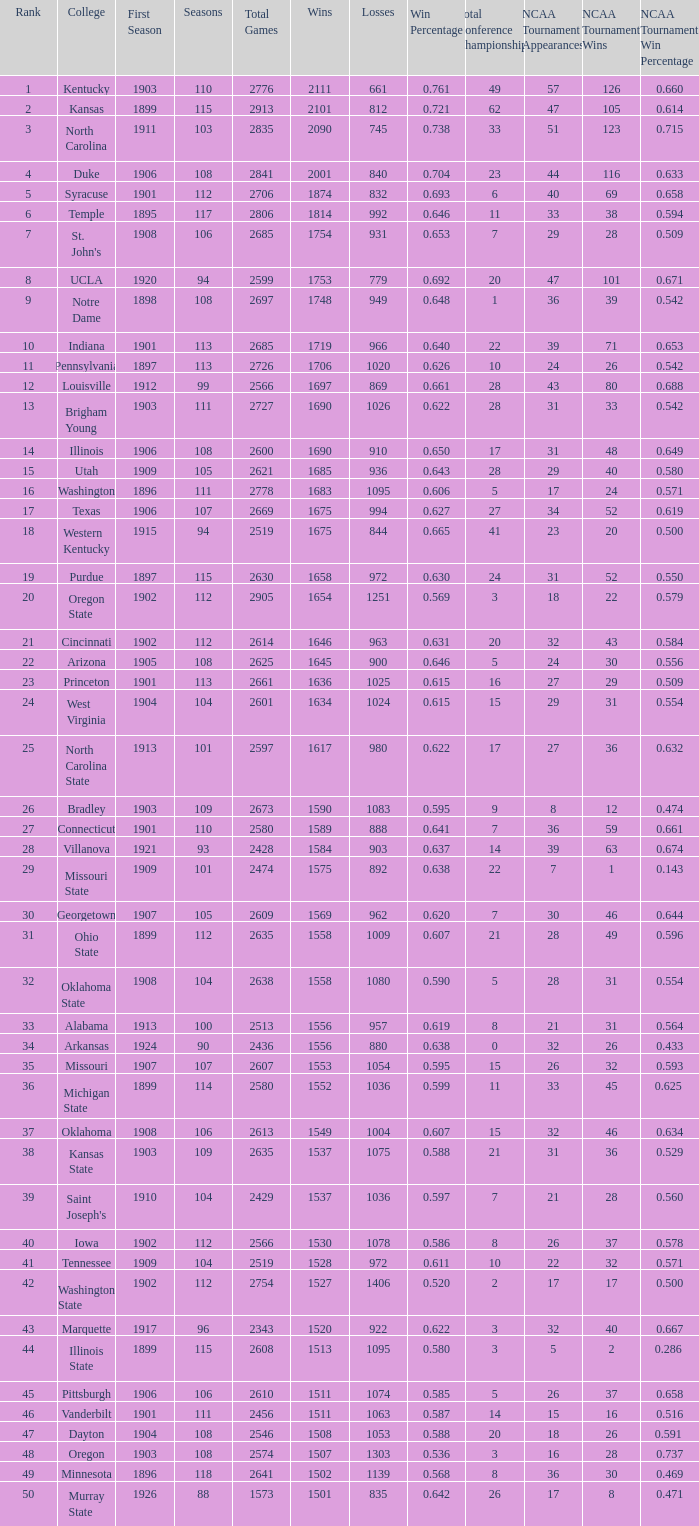What is the total number of rank with losses less than 992, North Carolina State College and a season greater than 101? 0.0. 